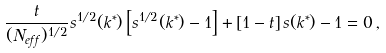Convert formula to latex. <formula><loc_0><loc_0><loc_500><loc_500>\frac { t } { ( N _ { e f f } ) ^ { 1 / 2 } } s ^ { 1 / 2 } ( k ^ { * } ) \left [ s ^ { 1 / 2 } ( k ^ { * } ) - 1 \right ] + \left [ 1 - t \right ] s ( k ^ { * } ) - 1 = 0 \, ,</formula> 